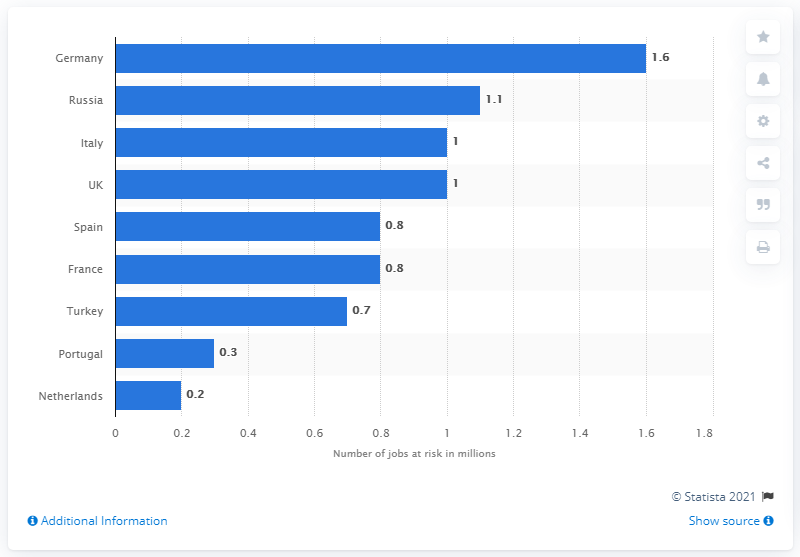Highlight a few significant elements in this photo. The travel and tourism sector in Germany is at risk of having 1.6 jobs. There is a potential risk of 1.1 jobs in the tourism sector in Russia. 